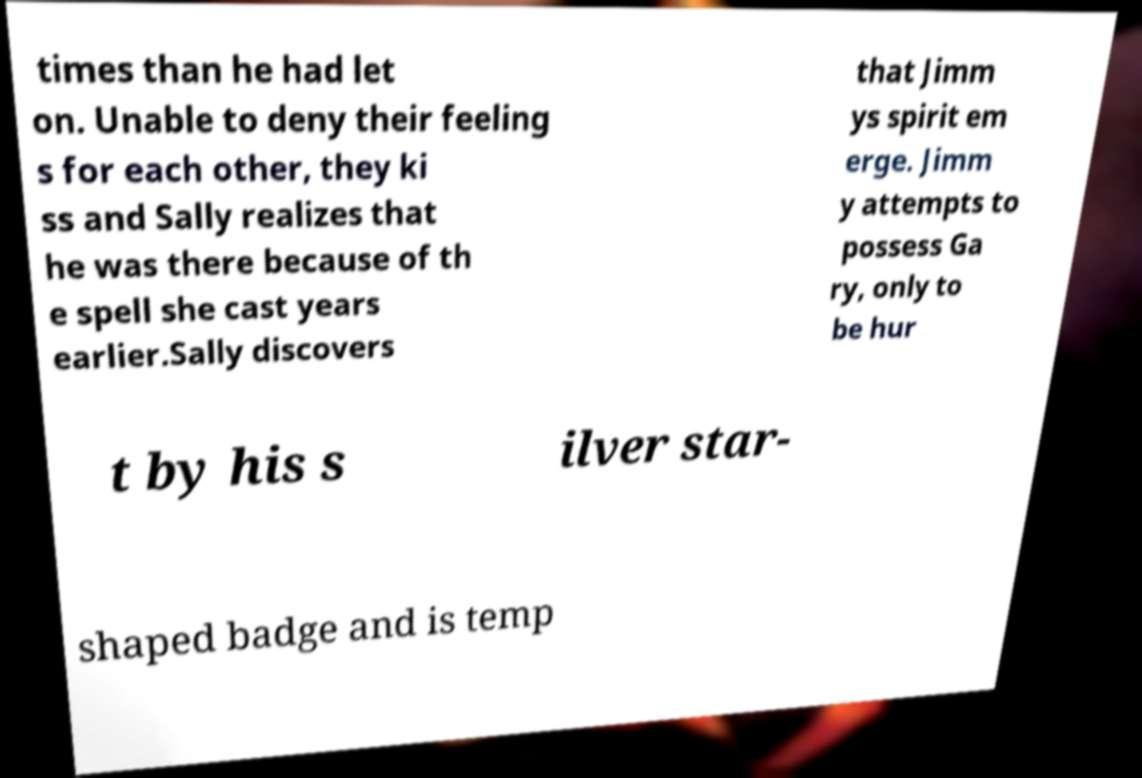Please identify and transcribe the text found in this image. times than he had let on. Unable to deny their feeling s for each other, they ki ss and Sally realizes that he was there because of th e spell she cast years earlier.Sally discovers that Jimm ys spirit em erge. Jimm y attempts to possess Ga ry, only to be hur t by his s ilver star- shaped badge and is temp 